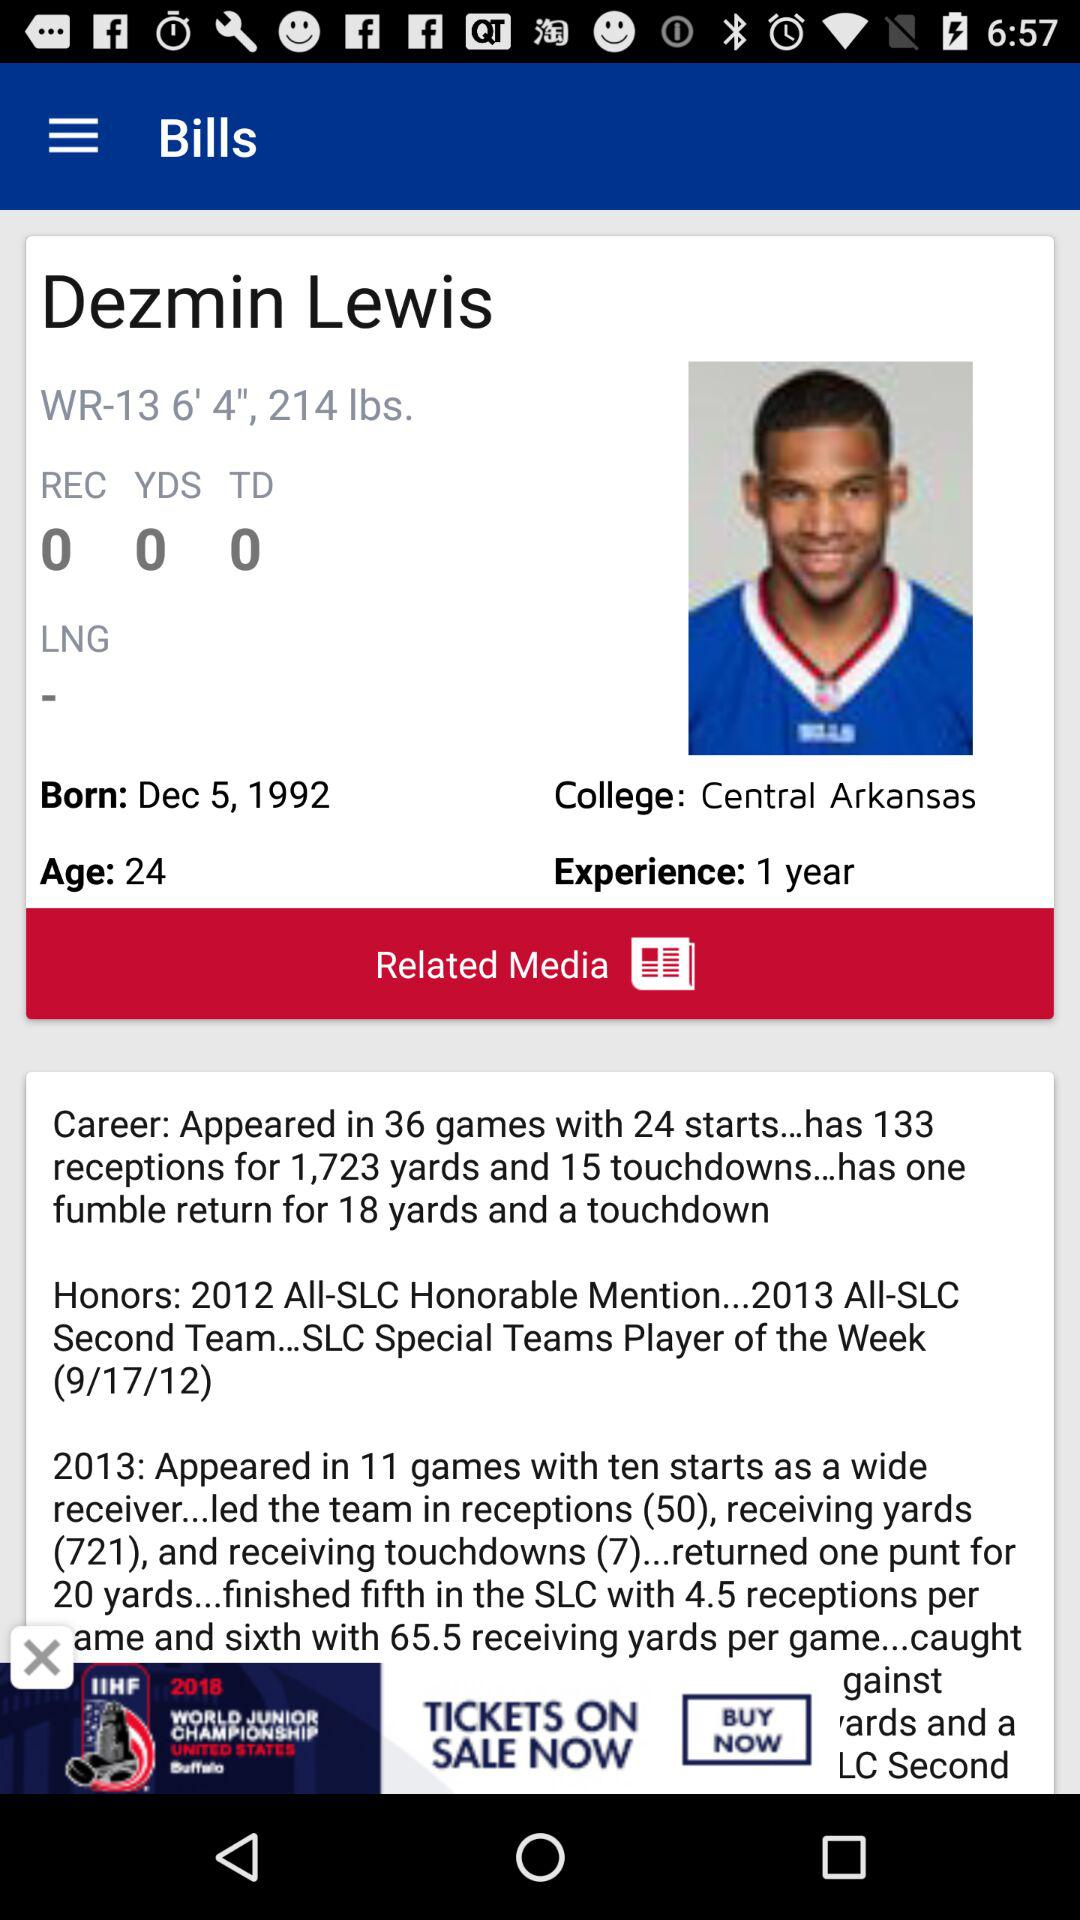How many years of experience does Dezmin Lewis have?
Answer the question using a single word or phrase. 1 